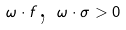Convert formula to latex. <formula><loc_0><loc_0><loc_500><loc_500>\omega \cdot f \text {, } \omega \cdot \sigma > 0</formula> 